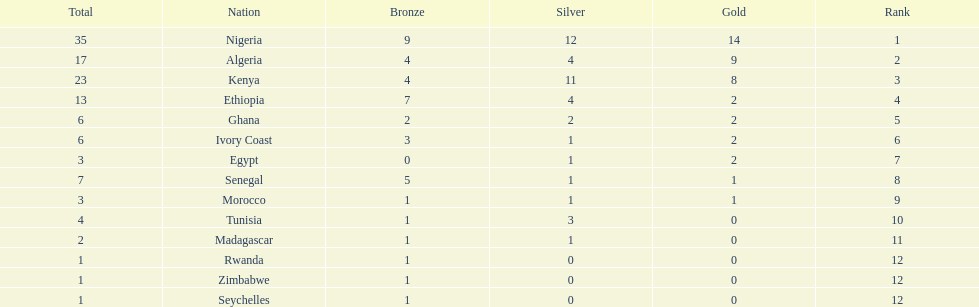The nation above algeria Nigeria. 